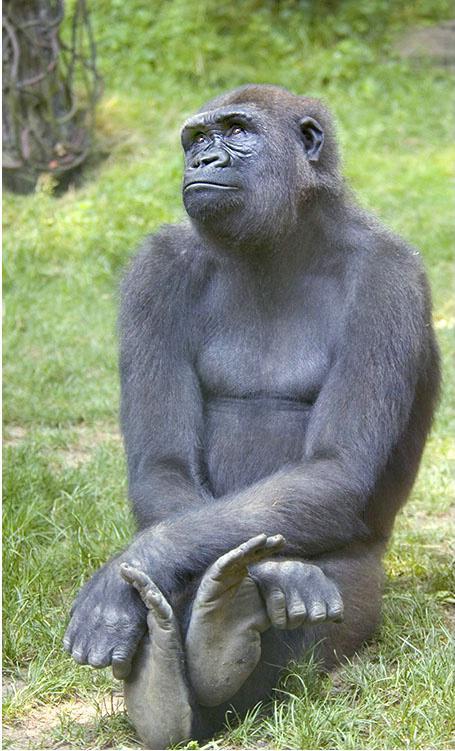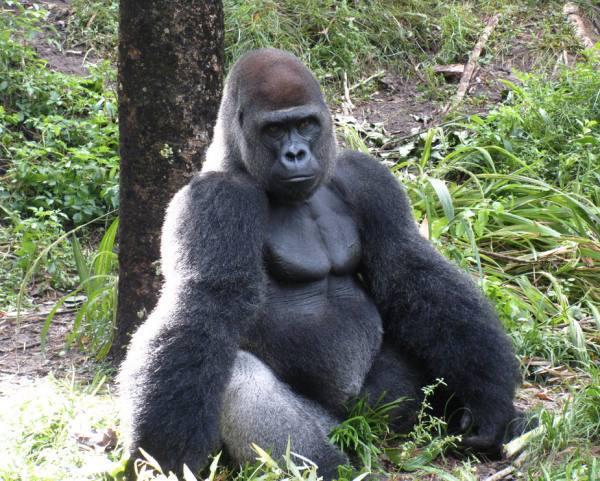The first image is the image on the left, the second image is the image on the right. Analyze the images presented: Is the assertion "The gorilla in the image on the left is touching the ground with both of it's arms." valid? Answer yes or no. No. 